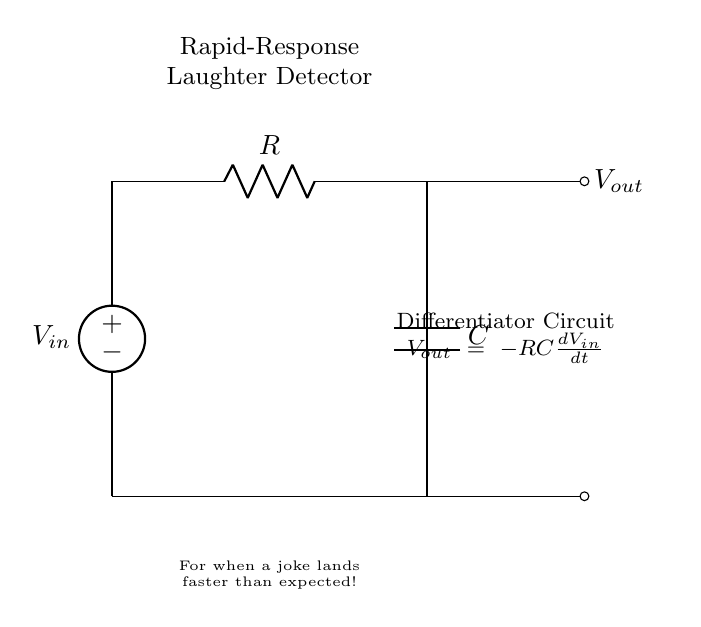What is the purpose of this circuit? The circuit is designed as a rapid-response laughter detector, using a differentiator circuit to process changes in voltage that occur when laughter happens. This is indicated in the circuit diagram at the bottom where it states, "For when a joke lands faster than expected!"
Answer: rapid-response laughter detector What component is responsible for the differentiation in this circuit? The capacitor is the component that stores and releases energy, allowing the circuit to respond to changes in the input signal quickly, thereby differentiating the voltage over time.
Answer: capacitor What is the relationship between Vout and Vin in this circuit? The equation given in the circuit diagram, Vout = -RC(dVin/dt), shows that Vout is the negative product of the resistance, capacitance, and the rate of change of Vin with respect to time, indicating a differentiation operation.
Answer: negative RC(dVin/dt) What does R represent in this circuit? R represents the resistance in ohms within the circuit, which controls the rate at which the capacitor charges and discharges, affecting the circuit's response time.
Answer: resistance What is the expected output when laughter occurs? When laughter occurs, it generates a rapid change in input voltage that is differentiated by the circuit, resulting in a spike in Vout, indicating detected laughter.
Answer: output spike What type of circuit is this? This is a differentiator circuit, which is characterized by its ability to output a voltage that represents the rate of change of the input voltage.
Answer: differentiator circuit 